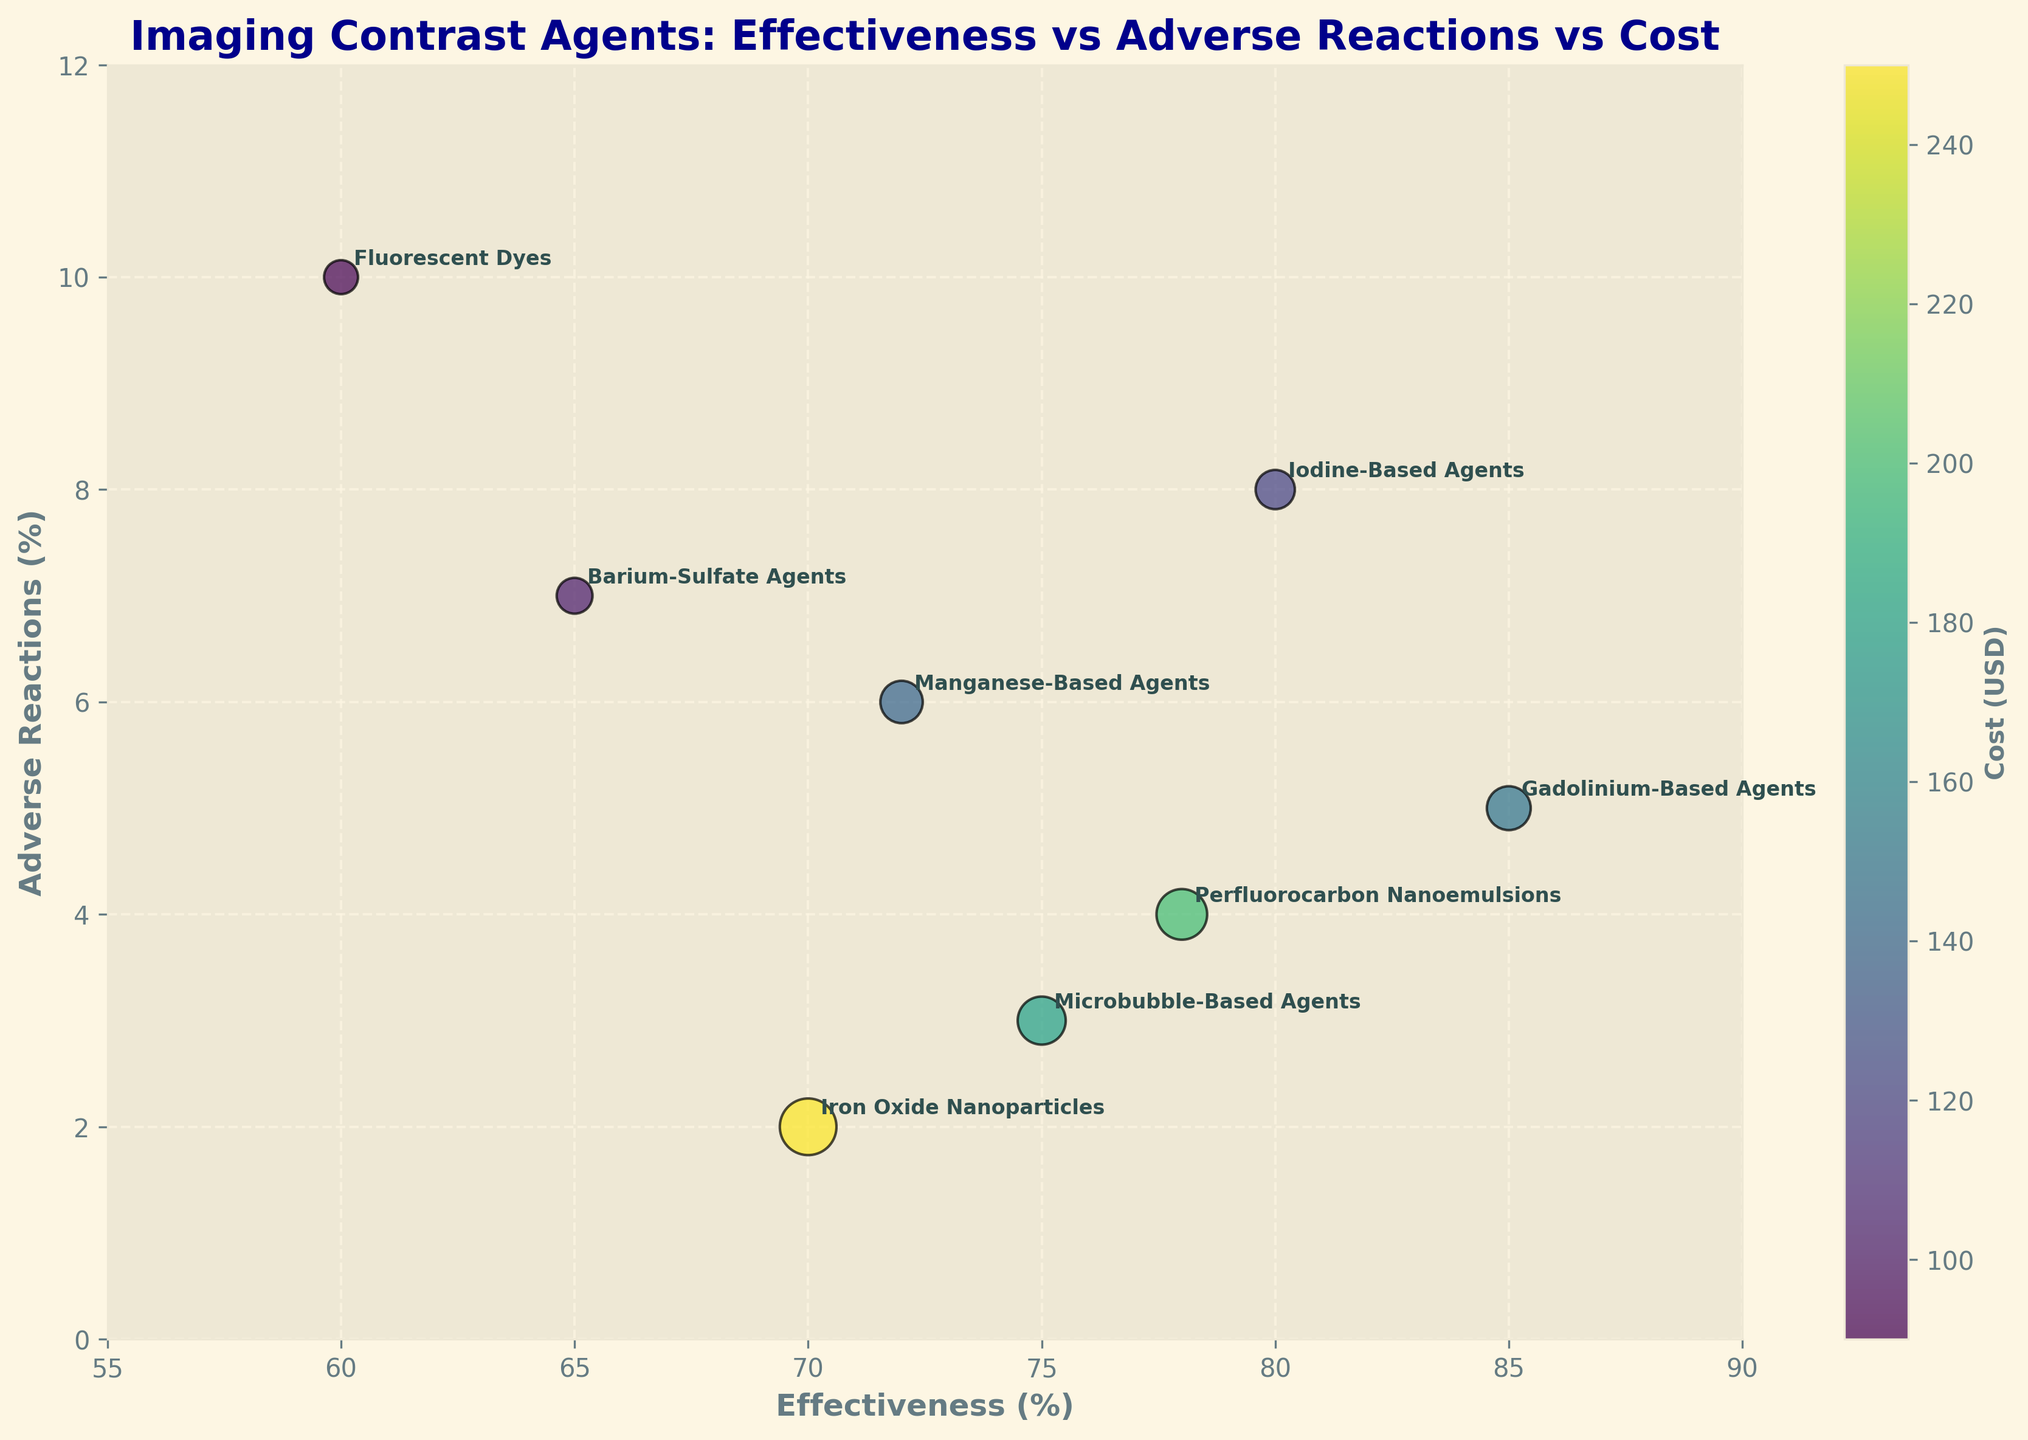what is the title of the chart? The title is written at the top center of the chart. By reading it, we can determine what the subject of the chart is.
Answer: Imaging Contrast Agents: Effectiveness vs Adverse Reactions vs Cost Which axis shows the 'Adverse Reactions (%)'? The 'Adverse Reactions (%)' is labeled on the y-axis of the chart.
Answer: y-axis How many contrast agents are depicted in the chart? Each contrast agent is represented by a bubble, and there are 8 different labels on the bubbles. Counting these labels gives the total number of contrast agents.
Answer: 8 Which contrast agent has the highest adverse reactions ratio? Looking at the y-axis value for each bubble, the one placed highest corresponds to the highest adverse reaction ratio. The agent labeled “Fluorescent Dyes” is at the top with 10%.
Answer: Fluorescent Dyes Which contrast agent has the lowest effectiveness? By examining the x-axis values, the bubble that is farthest to the left has the lowest effectiveness. This bubble corresponds to “Fluorescent Dyes” at 60%.
Answer: Fluorescent Dyes Which agent has the highest cost, and what is its effectiveness? The size and color of the bubbles represent the cost. The largest and darkest bubble is the Iron Oxide Nanoparticles. By examining its position on the x-axis, the effectiveness can be identified as 70%.
Answer: Iron Oxide Nanoparticles, 70% Which two contrast agents have the closest effectiveness values? By examining the x-axis values, identify bubbles that are closest to each other horizontally. “Manganese-Based Agents” at 72% and “Iron Oxide Nanoparticles” at 70% are the closest.
Answer: Manganese-Based Agents and Iron Oxide Nanoparticles Are there any agents with both high effectiveness and low adverse reactions? Effective agents are towards the right on the x-axis, and low adverse reaction agents are towards the bottom of the y-axis. “Gadolinium-Based Agents” are both highly effective (85%) and have relatively low adverse reactions (5%).
Answer: Gadolinium-Based Agents What is the cost difference between Microbubble-Based Agents and Barium-Sulfate Agents? Identify the cost for each agent by looking at the bubble size and color, and then subtract the lower value from the higher value. Microbubble-Based Agents cost $180, and Barium-Sulfate Agents cost $100, so the difference is $180 - $100 = $80.
Answer: $80 